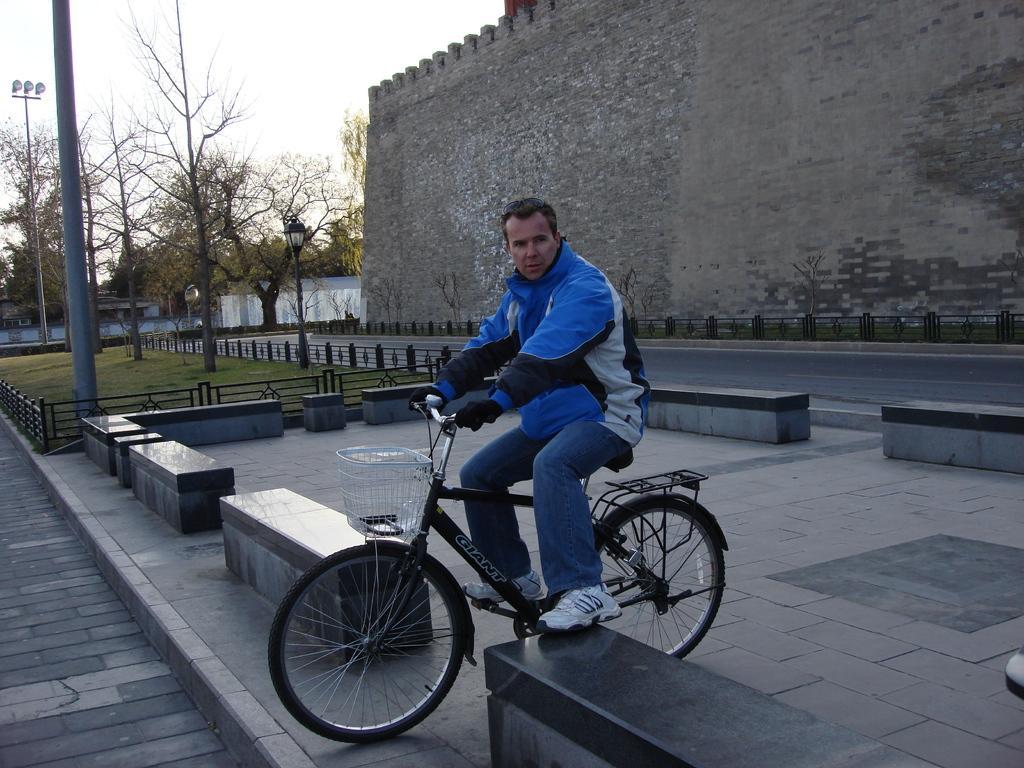Describe this image in one or two sentences. a person is riding a bicycle on the road there are many branches near to him there are trees building and clear sky 